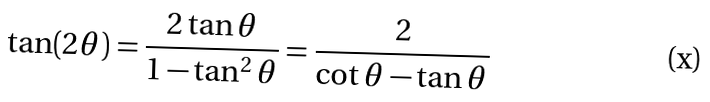Convert formula to latex. <formula><loc_0><loc_0><loc_500><loc_500>\tan ( 2 \theta ) = { \frac { 2 \tan \theta } { 1 - \tan ^ { 2 } \theta } } = { \frac { 2 } { \cot \theta - \tan \theta } }</formula> 